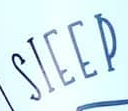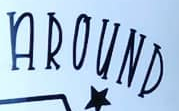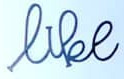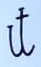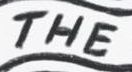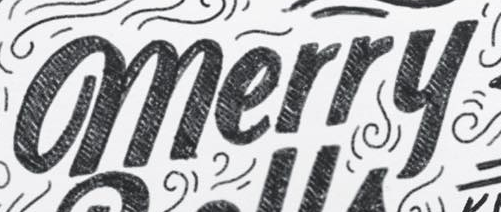What words can you see in these images in sequence, separated by a semicolon? SIEEP; AROUND; like; it; THE; merry 